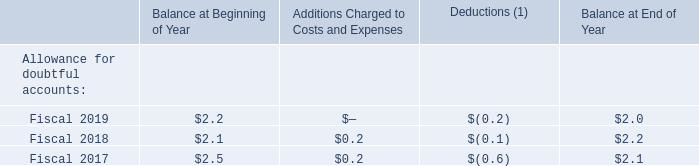A summary of additions and deductions related to the allowance for doubtful accounts for the years ended March 31, 2019, 2018 and 2017 follows (amounts in millions):
(1) Deductions represent uncollectible accounts written off, net of recoveries.
What do deductions represent? Uncollectible accounts written off, net of recoveries. What were the deductions in 2018?
Answer scale should be: million. (0.1). Which years does the table provide information for the additions and deductions related to the allowance for doubtful accounts? 2019, 2018, 2017. What was the change in the Balance at Beginning of Year between 2017 and 2018?
Answer scale should be: million. 2.1-2.5
Answer: -0.4. How many years did the balance at end of the year exceed $2 million? 2019##2018##2017
Answer: 3. What was the percentage change in the deductions between 2018 and 2019?
Answer scale should be: percent. (-0.2-(-0.1))/-0.1
Answer: 100. 